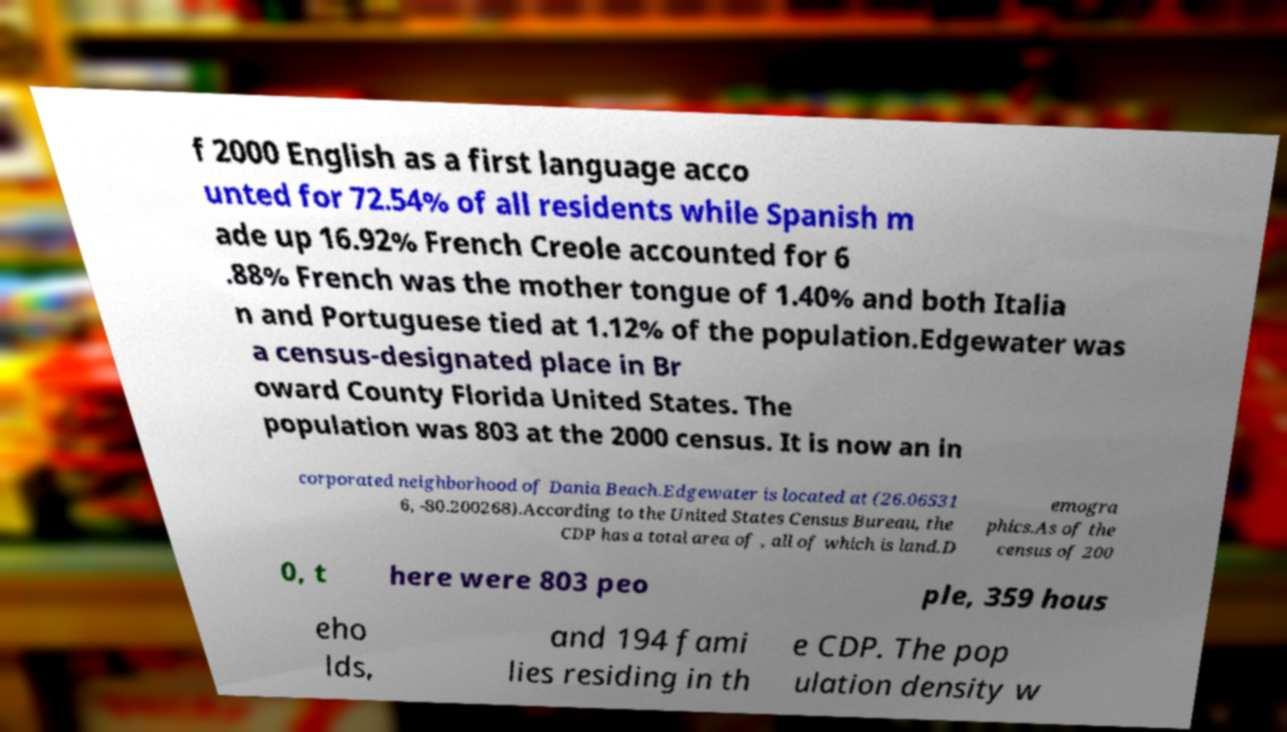Could you assist in decoding the text presented in this image and type it out clearly? f 2000 English as a first language acco unted for 72.54% of all residents while Spanish m ade up 16.92% French Creole accounted for 6 .88% French was the mother tongue of 1.40% and both Italia n and Portuguese tied at 1.12% of the population.Edgewater was a census-designated place in Br oward County Florida United States. The population was 803 at the 2000 census. It is now an in corporated neighborhood of Dania Beach.Edgewater is located at (26.06531 6, -80.200268).According to the United States Census Bureau, the CDP has a total area of , all of which is land.D emogra phics.As of the census of 200 0, t here were 803 peo ple, 359 hous eho lds, and 194 fami lies residing in th e CDP. The pop ulation density w 